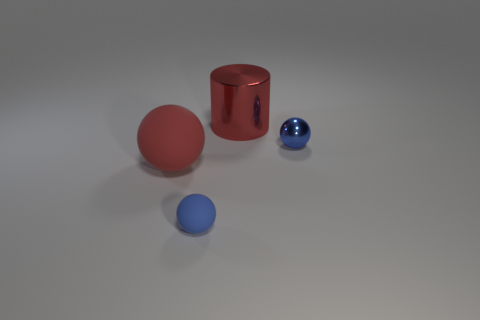Is there another green matte cylinder of the same size as the cylinder? no 